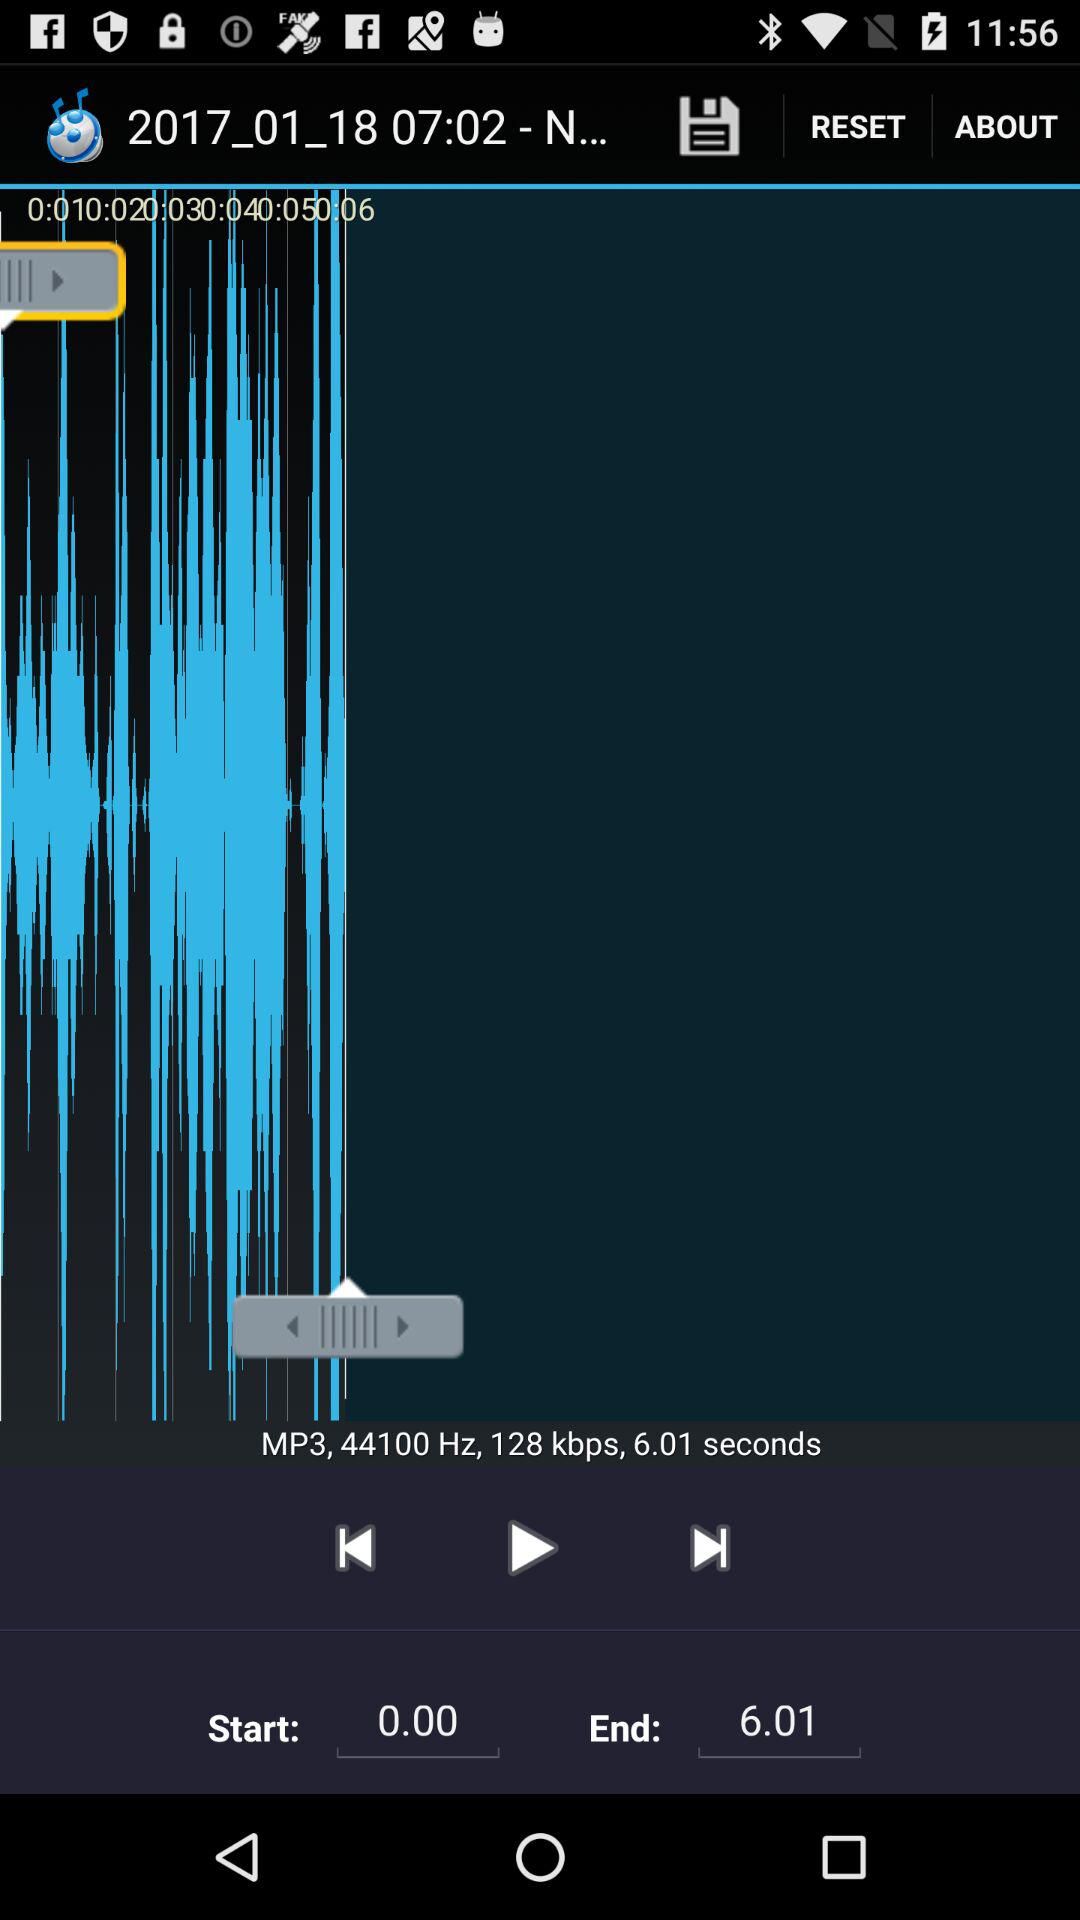What is the speed in kbps? The speed in kbps is 128. 